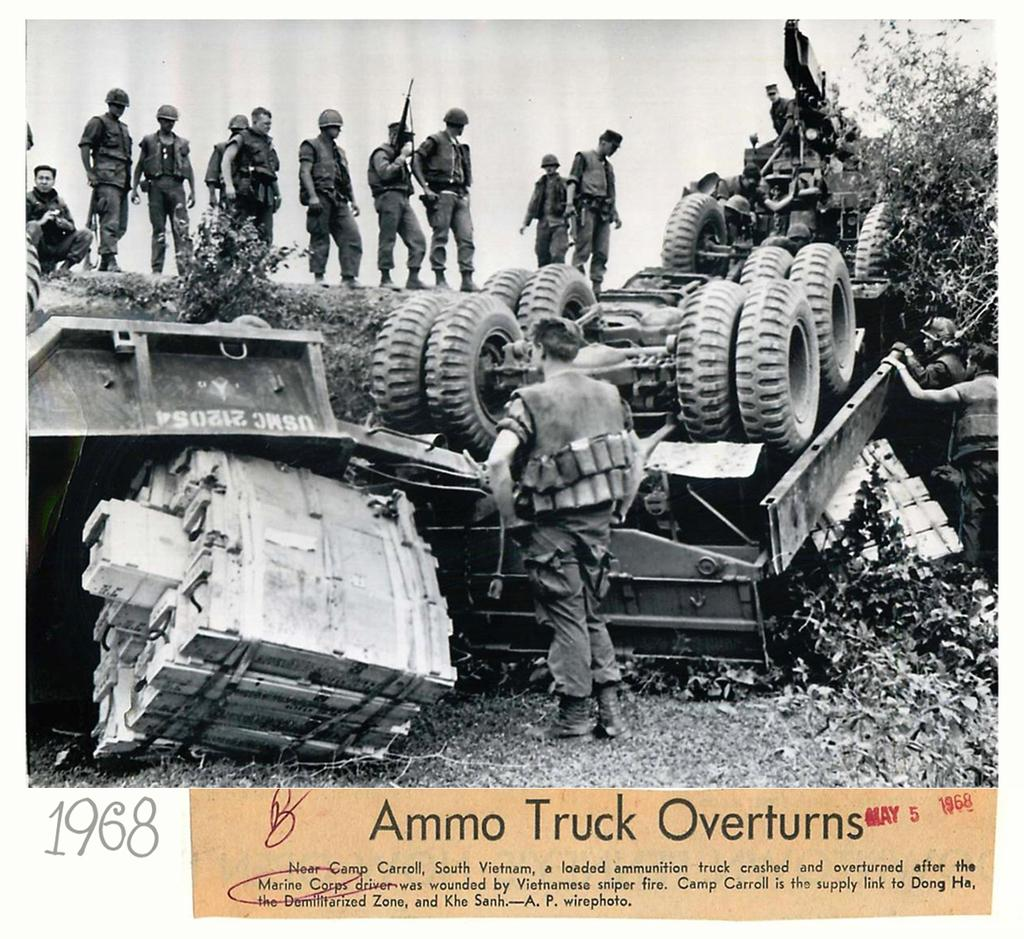What is the color scheme of the image? The image is black and white. What can be seen in the image that appears to be damaged? A vehicle is damaged in the image. What are the men in the image wearing? The men are wearing bulletproof jackets in the image. What are the men doing in the image? The men are looking at the damaged vehicle. What type of vegetation is on the right side of the image? There are plants on the right side of the image. What type of machine is the man using to perform a knee replacement surgery in the image? There is no machine or knee replacement surgery present in the image; it features a damaged vehicle and men wearing bulletproof jackets. 